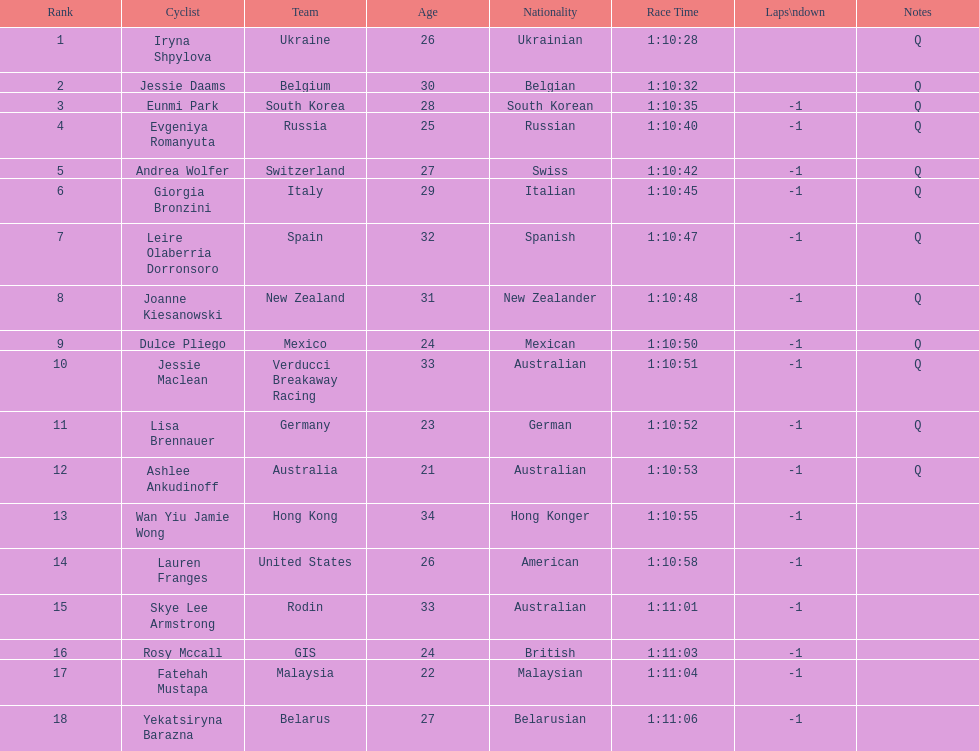Who is the last cyclist listed? Yekatsiryna Barazna. 